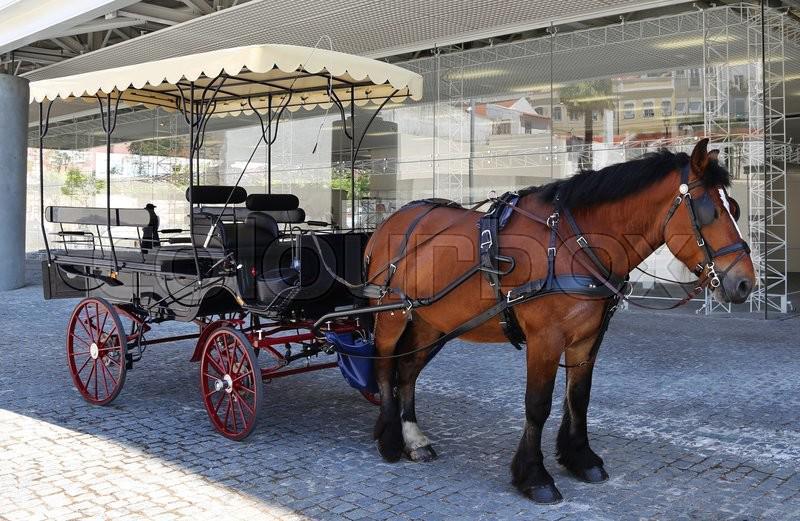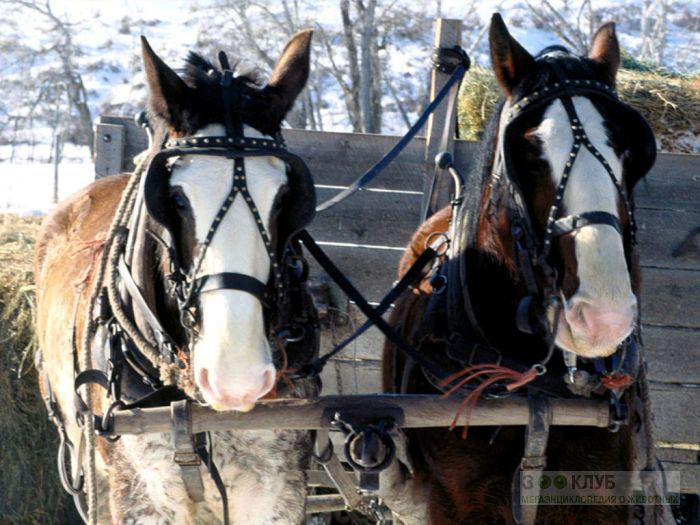The first image is the image on the left, the second image is the image on the right. For the images displayed, is the sentence "In one of the images the wagon is being pulled by two horses." factually correct? Answer yes or no. Yes. 